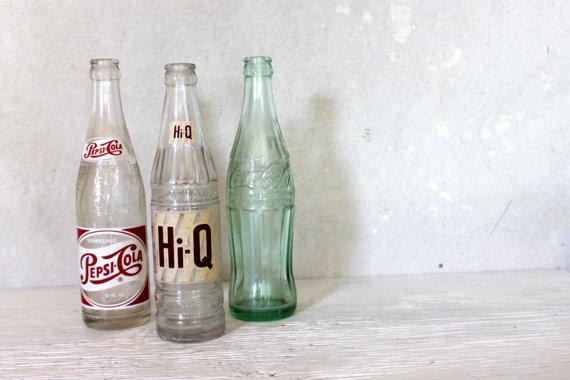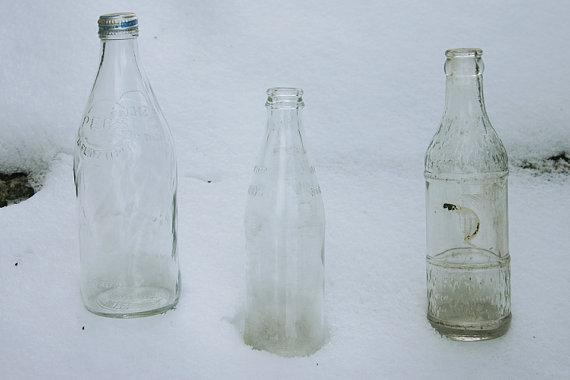The first image is the image on the left, the second image is the image on the right. Analyze the images presented: Is the assertion "There are exactly six bottles." valid? Answer yes or no. Yes. The first image is the image on the left, the second image is the image on the right. Evaluate the accuracy of this statement regarding the images: "In one image all the bottles are made of plastic.". Is it true? Answer yes or no. No. 